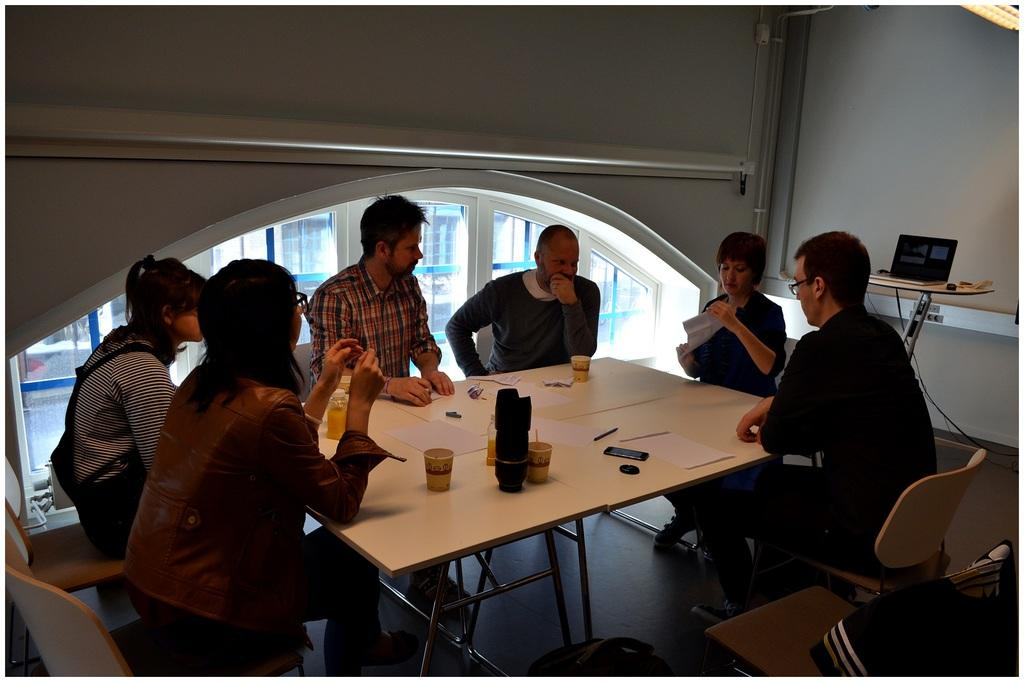What are the people in the image doing? The people in the image are sitting on chairs. What is in front of the chairs? There is a table in front of the chairs. What can be seen on the table? There is a glass, a mobile phone, a paper, and a pen on the table. What type of grass is growing on the table in the image? There is no grass present on the table in the image. What toy can be seen being used by the people in the image? There are no toys visible in the image; the people are sitting on chairs and there are objects on the table. 